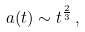<formula> <loc_0><loc_0><loc_500><loc_500>a ( t ) \sim t ^ { \frac { 2 } { 3 } } \, ,</formula> 